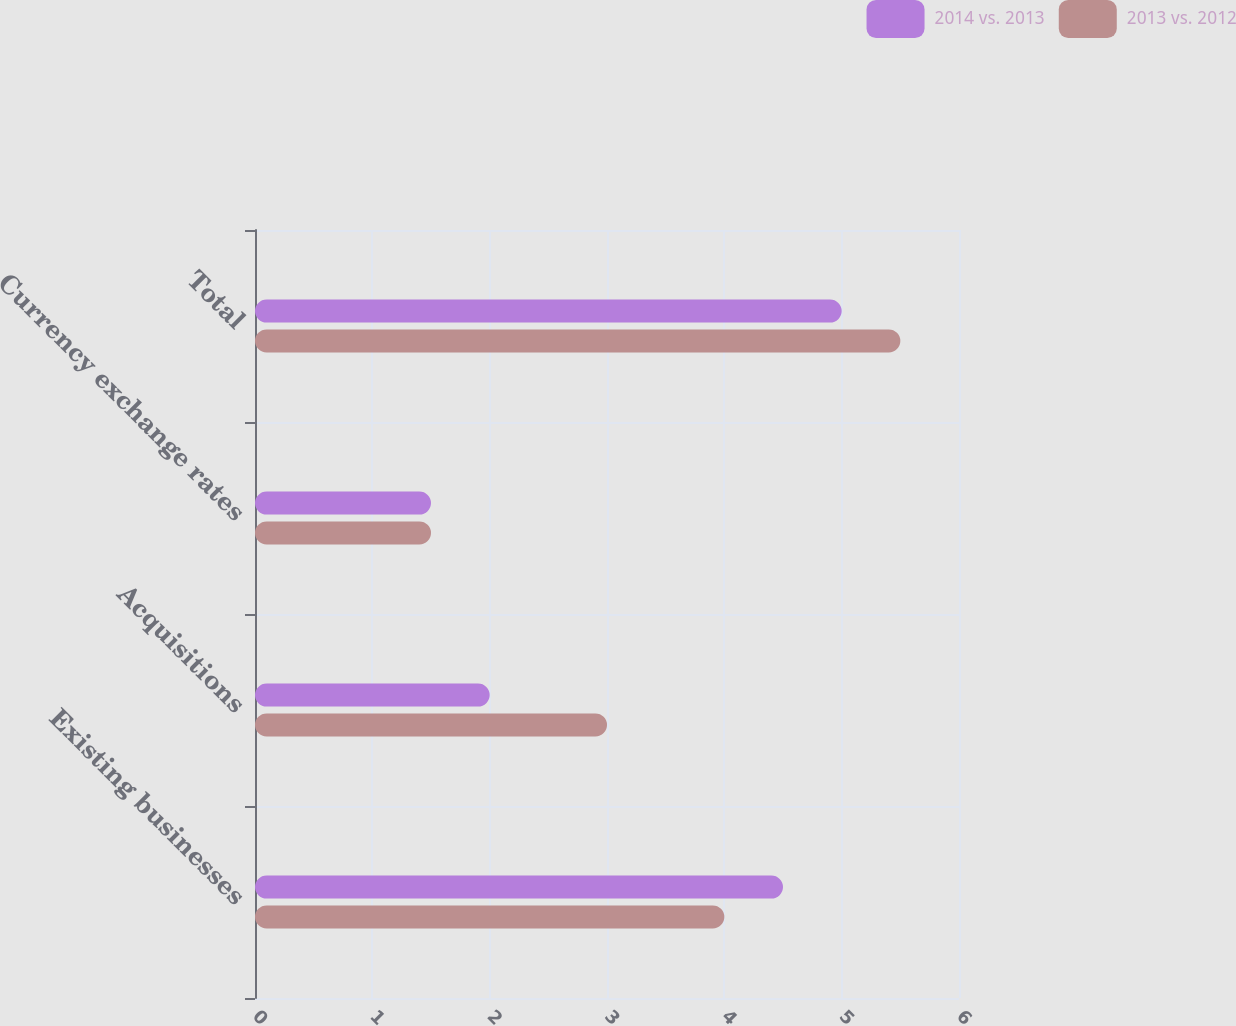Convert chart to OTSL. <chart><loc_0><loc_0><loc_500><loc_500><stacked_bar_chart><ecel><fcel>Existing businesses<fcel>Acquisitions<fcel>Currency exchange rates<fcel>Total<nl><fcel>2014 vs. 2013<fcel>4.5<fcel>2<fcel>1.5<fcel>5<nl><fcel>2013 vs. 2012<fcel>4<fcel>3<fcel>1.5<fcel>5.5<nl></chart> 